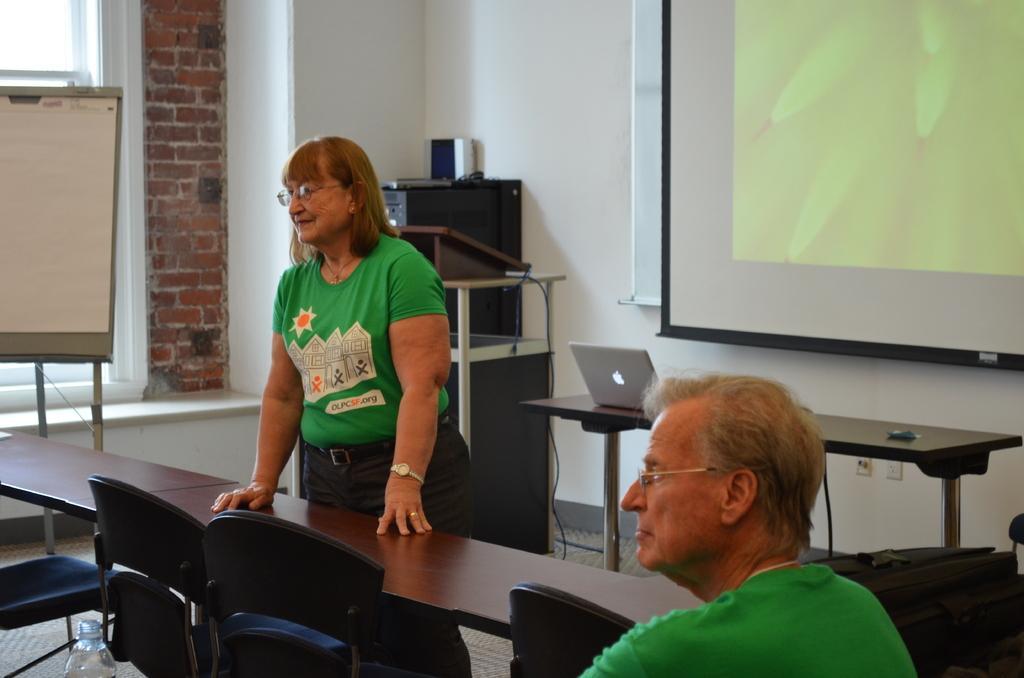Please provide a concise description of this image. The picture is taken in a classroom. In the foreground of the picture there are tables, chairs, bottle, a man and a woman. On the left there are board, stand, brick wall and window. In center of the background there are table, laptop, podium, cable, desktop and projector screen. 